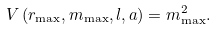Convert formula to latex. <formula><loc_0><loc_0><loc_500><loc_500>V \left ( { r _ { \max } , m _ { \max } , l , a } \right ) = m _ { \max } ^ { 2 } .</formula> 